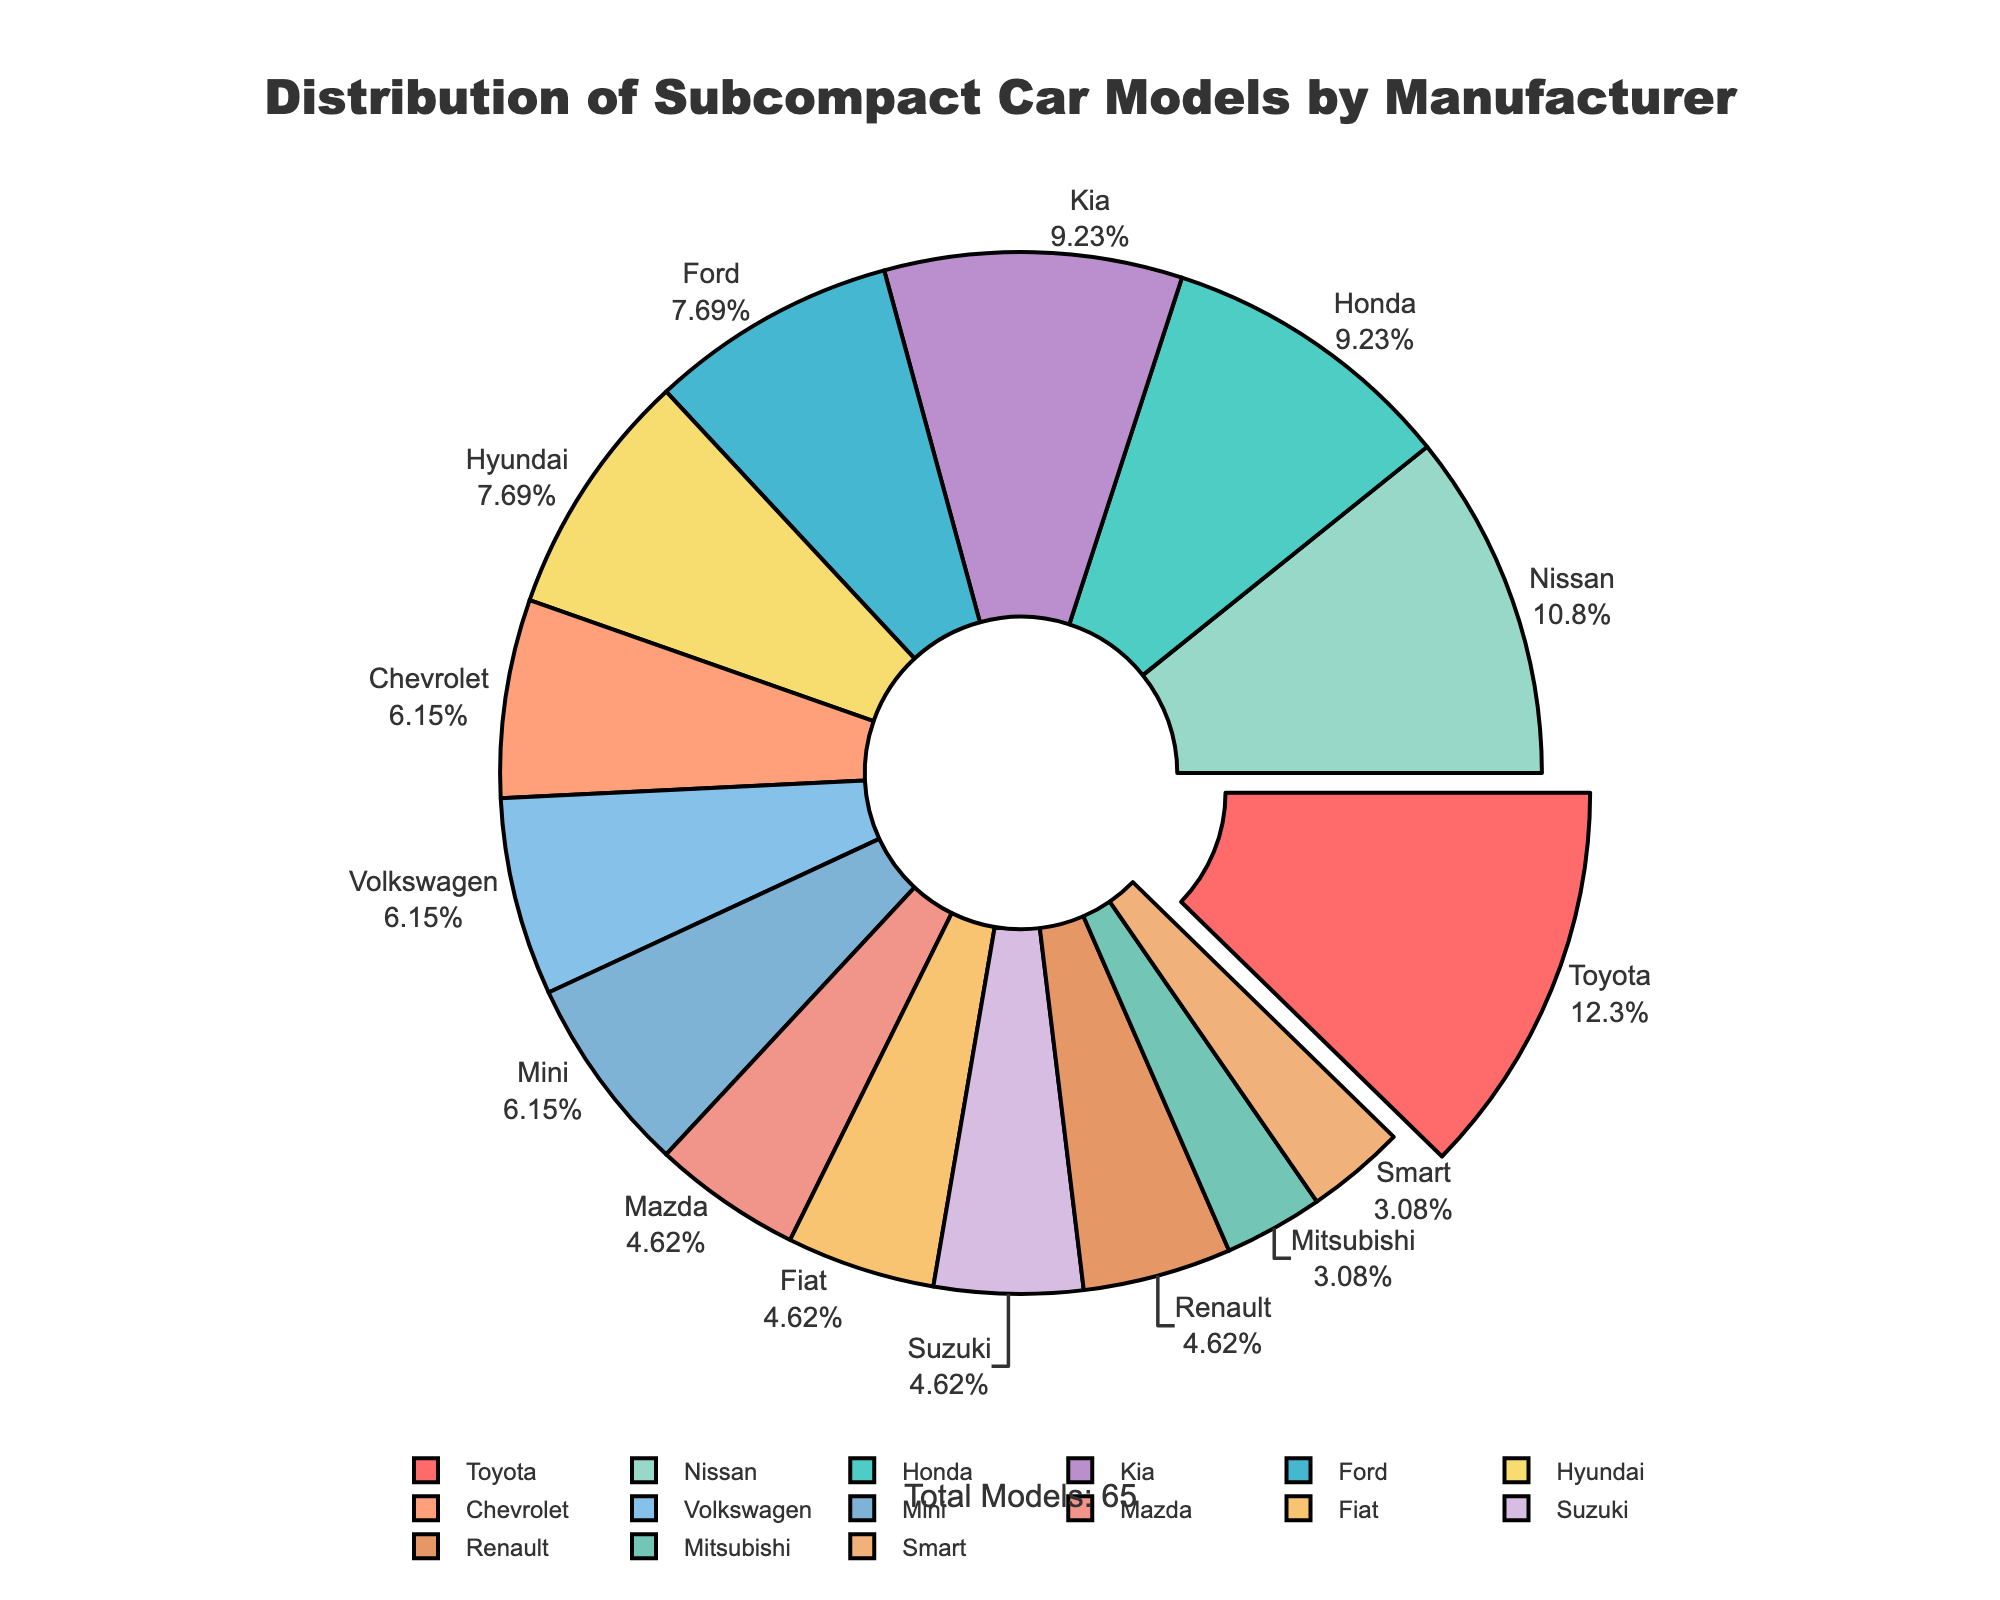Which manufacturer has the largest number of subcompact car models? Toyota is visually separated from the rest with a slightly pulled-out segment and has the largest portion of the pie chart. This indicates that Toyota has the highest number of subcompact car models.
Answer: Toyota Which manufacturer has the smallest number of subcompact car models? Both Mitsubishi and Smart segments are the smallest and have equal size, indicating that they have the smallest number of subcompact car models.
Answer: Mitsubishi, Smart How many more subcompact models does Honda have compared to Ford? From the pie chart, Honda has 6 models, and Ford has 5 models. The difference is 6 - 5 = 1.
Answer: 1 What percentage of the total does Toyota's subcompact car models represent? Toyota’s segment is labeled with both the name and the percentage. Observing the pie chart, Toyota represents 19.05% of the total subcompact car models.
Answer: 19.05% How does the number of subcompact models from Kia compare to that from Hyundai? The pie chart shows that Kia and Hyundai have segments of roughly similar size. Referring to the data, both Kia and Hyundai have 5 and 6 models respectively, Kia has only one more than Hyundai.
Answer: Kia has 1 more What is the total number of subcompact car models across all manufacturers? The total number is annotated at the bottom of the chart, summing all given models in the data: 8+6+5+4+7+5+6+3+4+3+2+3+2+4+3 = 62.
Answer: 62 Which manufacturers have exactly four subcompact car models? The equal-sized segments for four models can be identified visually. They are labeled as Chevrolet, Volkswagen, and Mini.
Answer: Chevrolet, Volkswagen, Mini If we combine the subcompact car models from Nissan and Honda, how many models would there be in total? According to the chart, Nissan has 7 and Honda has 6 subcompact car models. Combined, they would total 7 + 6 = 13.
Answer: 13 Which manufacturer’s segment follows directly after Toyota in a clockwise direction on the pie chart? The segment immediately following Toyota’s (which is slightly pulled out) in a clockwise direction is labeled as Nissan.
Answer: Nissan 